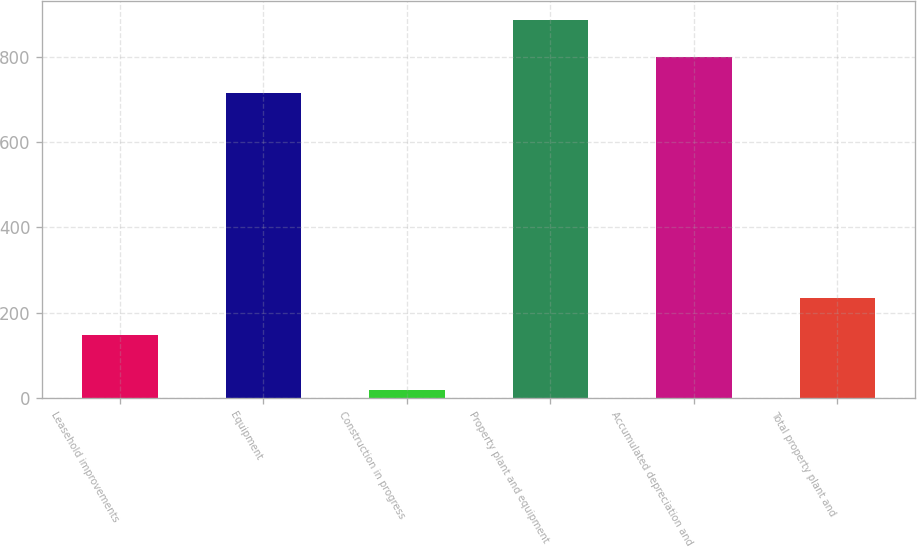Convert chart. <chart><loc_0><loc_0><loc_500><loc_500><bar_chart><fcel>Leasehold improvements<fcel>Equipment<fcel>Construction in progress<fcel>Property plant and equipment<fcel>Accumulated depreciation and<fcel>Total property plant and<nl><fcel>148<fcel>714<fcel>19<fcel>886.4<fcel>800.2<fcel>234.2<nl></chart> 